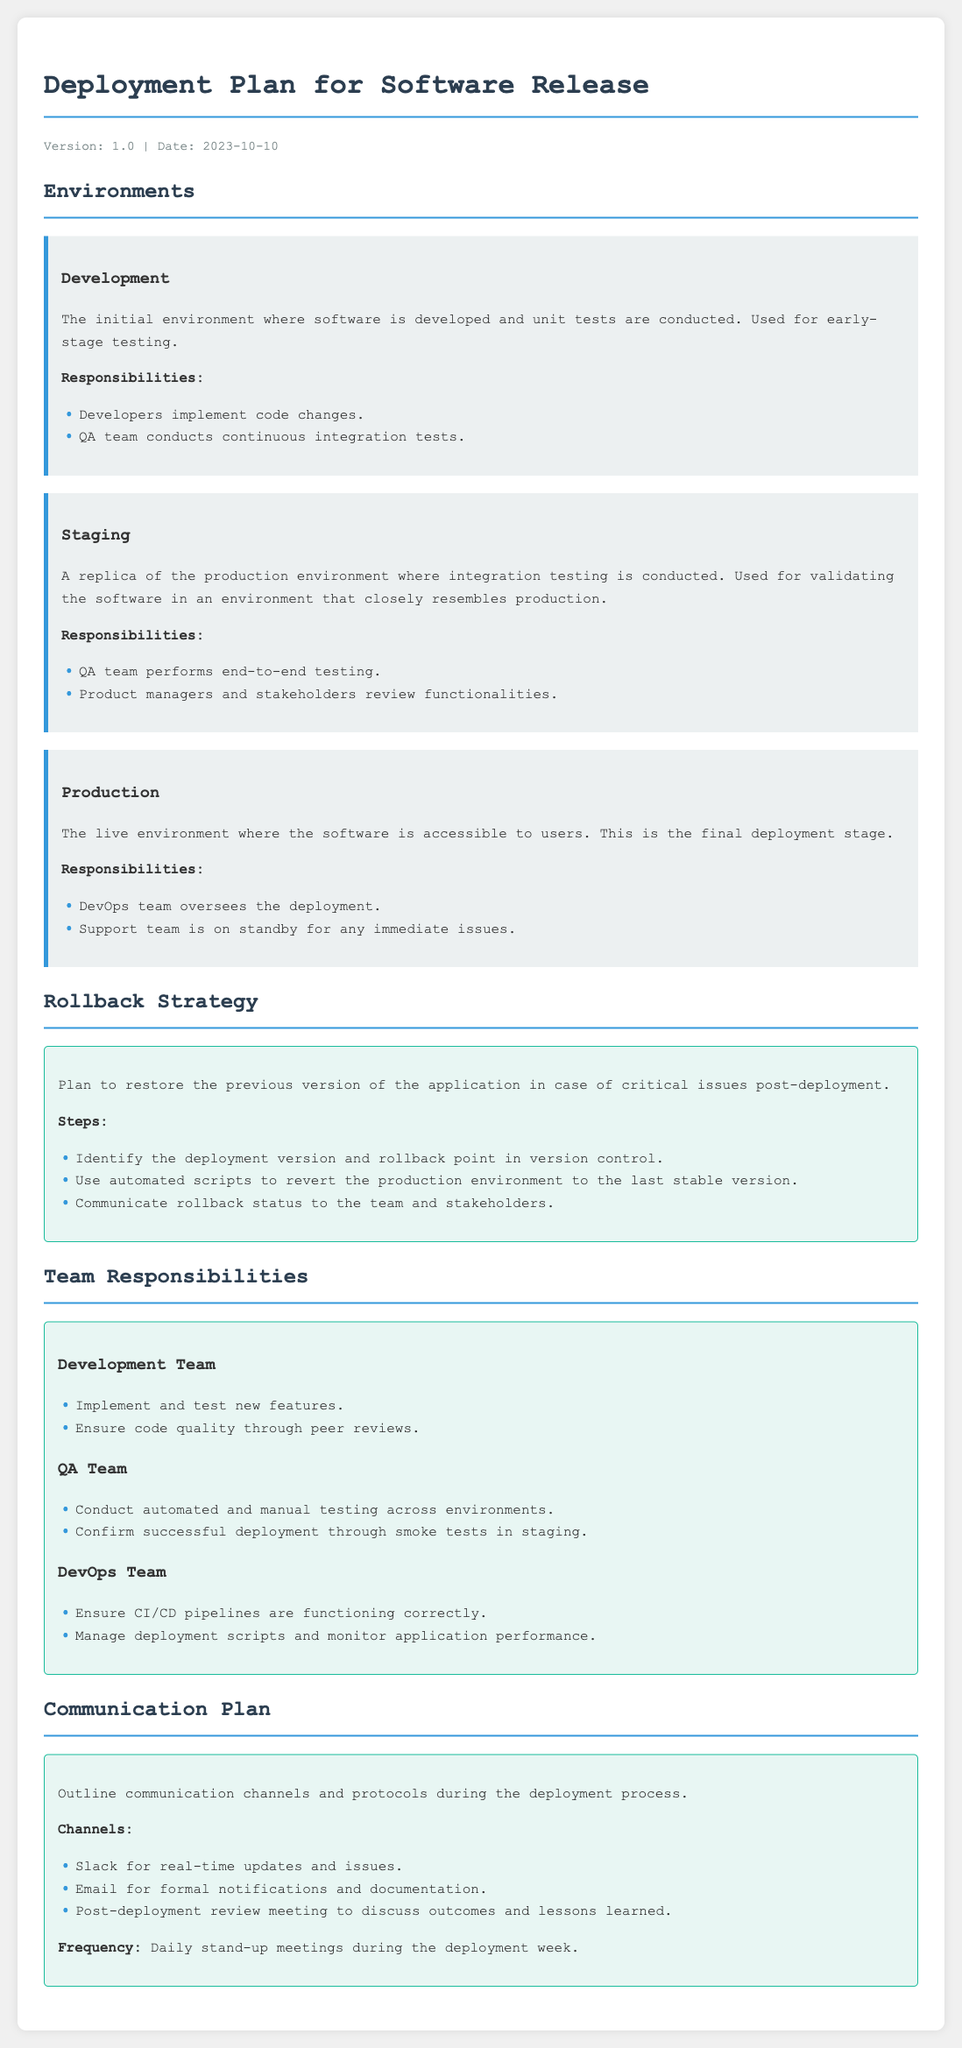What is the version of the deployment plan? The version of the deployment plan is stated in the meta-info section of the document.
Answer: 1.0 What is the date of the deployment plan? The date is provided in the meta-info section of the document.
Answer: 2023-10-10 Who oversees deployment in the production environment? This information comes from the responsibilities listed under the production environment.
Answer: DevOps team What type of testing occurs in the staging environment? This is described in the responsibilities section for the staging environment.
Answer: End-to-end testing What are the communication channels mentioned? The document lists communication channels in the communication plan section.
Answer: Slack, Email What is the first step in the rollback strategy? The steps are detailed in the rollback strategy section of the document.
Answer: Identify the deployment version What team confirms successful deployment through smoke tests? This is specified under the QA team's responsibilities.
Answer: QA Team How often are stand-up meetings held during deployment? The frequency is addressed in the communication plan section.
Answer: Daily What does the development team ensure through peer reviews? This can be found in the responsibilities for the development team.
Answer: Code quality 